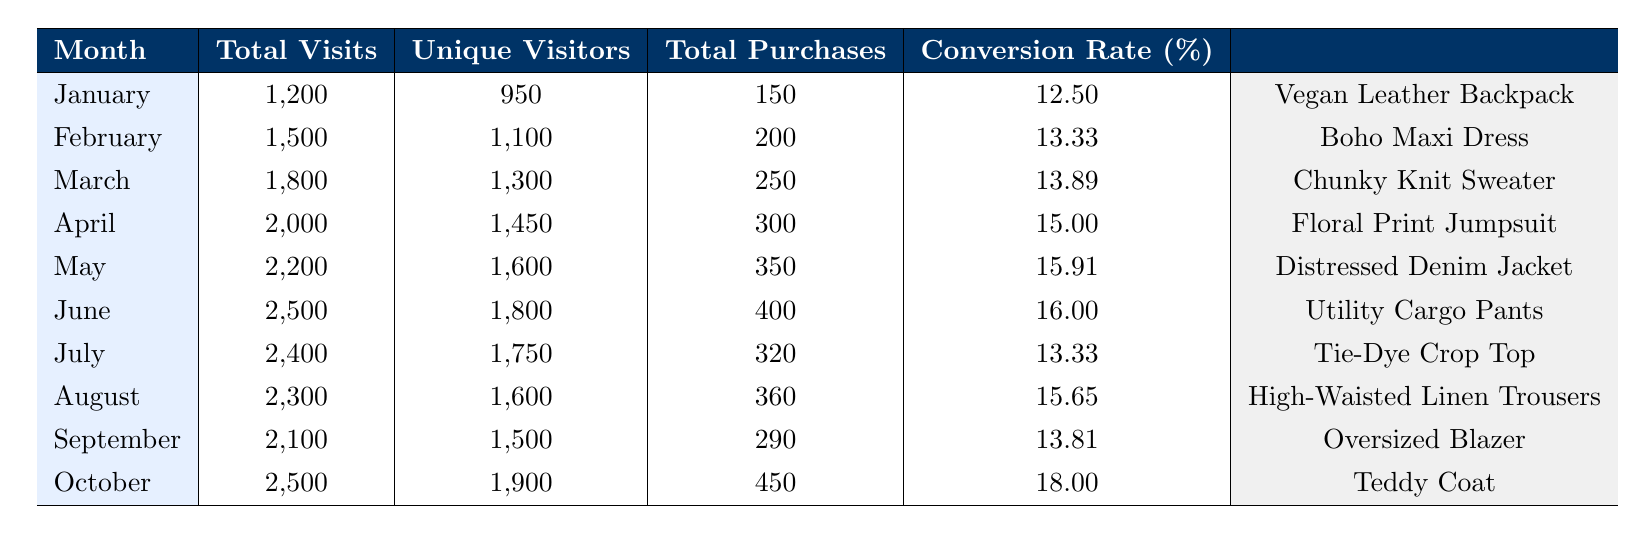What was the top-selling item in October? In the row for October, the top-selling item listed is "Teddy Coat."
Answer: Teddy Coat Which month had the highest conversion rate? Looking through the conversion rates listed, October shows the highest value at 18.0 percent.
Answer: October What was the average total purchases from January to June? Total purchases from January to June are 150, 200, 250, 300, 350, and 400. Summing these gives 1750, and dividing by 6 months results in an average of 291.67.
Answer: 291.67 Did the conversion rate increase from January to April? The conversion rates are 12.5 in January, 13.33 in February, 13.89 in March, and 15.0 in April. Since each value is greater than the previous, the conversion rate did indeed increase.
Answer: Yes What is the percentage increase in total purchases from May to June? Total purchases in May were 350 and in June were 400. The change is 400 - 350 = 50. The percentage increase is (50/350) * 100 = 14.29 percent.
Answer: 14.29 What was the total number of visits in August and September? Adding the total visits for August (2300) and September (2100) gives us 2300 + 2100 = 4400.
Answer: 4400 Is the total number of unique visitors greater in July compared to June? In July, unique visitors were 1750 and in June, there were 1800. Since 1750 is less than 1800, the statement is false.
Answer: No Which month had fewer unique visitors, July or August? July had 1750 unique visitors while August had 1600. Since 1600 is less than 1750, August had fewer unique visitors.
Answer: August 